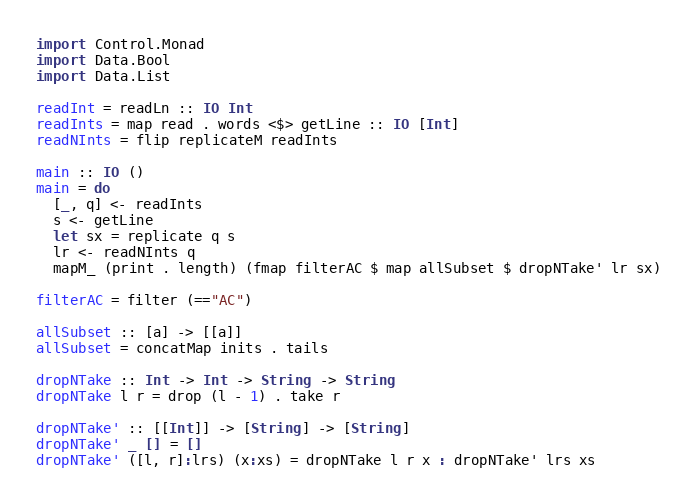Convert code to text. <code><loc_0><loc_0><loc_500><loc_500><_Haskell_>import Control.Monad
import Data.Bool
import Data.List

readInt = readLn :: IO Int
readInts = map read . words <$> getLine :: IO [Int]
readNInts = flip replicateM readInts

main :: IO ()
main = do
  [_, q] <- readInts
  s <- getLine
  let sx = replicate q s
  lr <- readNInts q
  mapM_ (print . length) (fmap filterAC $ map allSubset $ dropNTake' lr sx)

filterAC = filter (=="AC")

allSubset :: [a] -> [[a]]
allSubset = concatMap inits . tails

dropNTake :: Int -> Int -> String -> String
dropNTake l r = drop (l - 1) . take r

dropNTake' :: [[Int]] -> [String] -> [String]
dropNTake' _ [] = []
dropNTake' ([l, r]:lrs) (x:xs) = dropNTake l r x : dropNTake' lrs xs</code> 